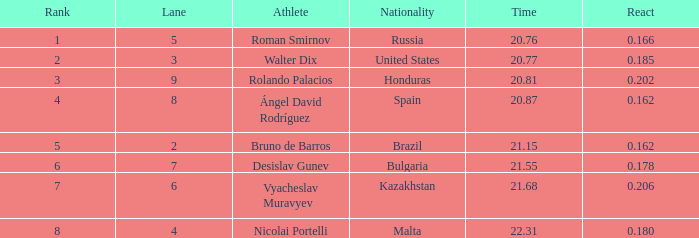What's Russia's lane when they were ranked before 1? None. 